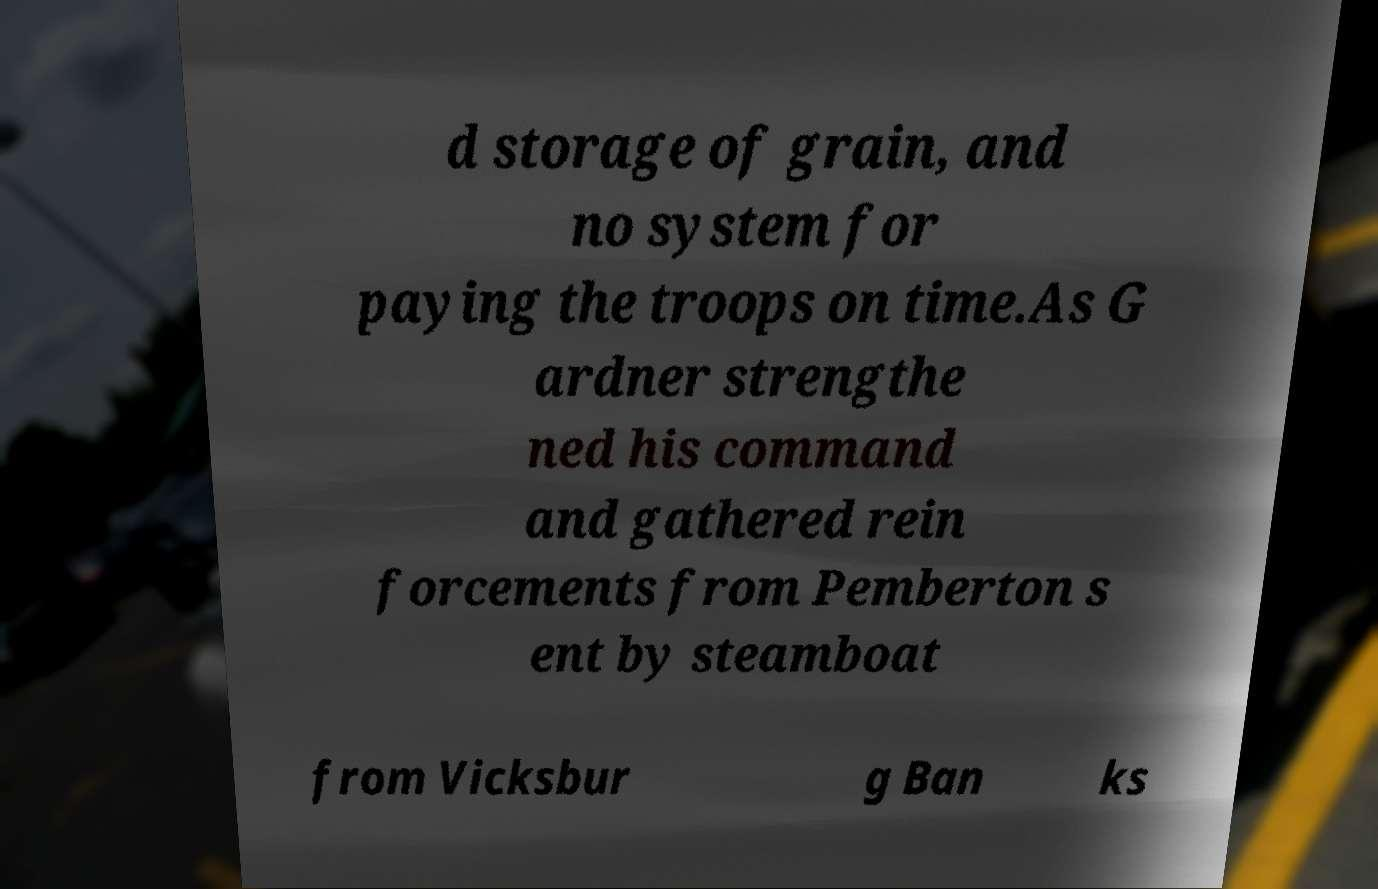Could you assist in decoding the text presented in this image and type it out clearly? d storage of grain, and no system for paying the troops on time.As G ardner strengthe ned his command and gathered rein forcements from Pemberton s ent by steamboat from Vicksbur g Ban ks 